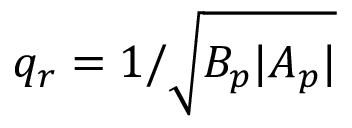<formula> <loc_0><loc_0><loc_500><loc_500>q _ { r } = 1 / \sqrt { B _ { p } | A _ { p } | }</formula> 